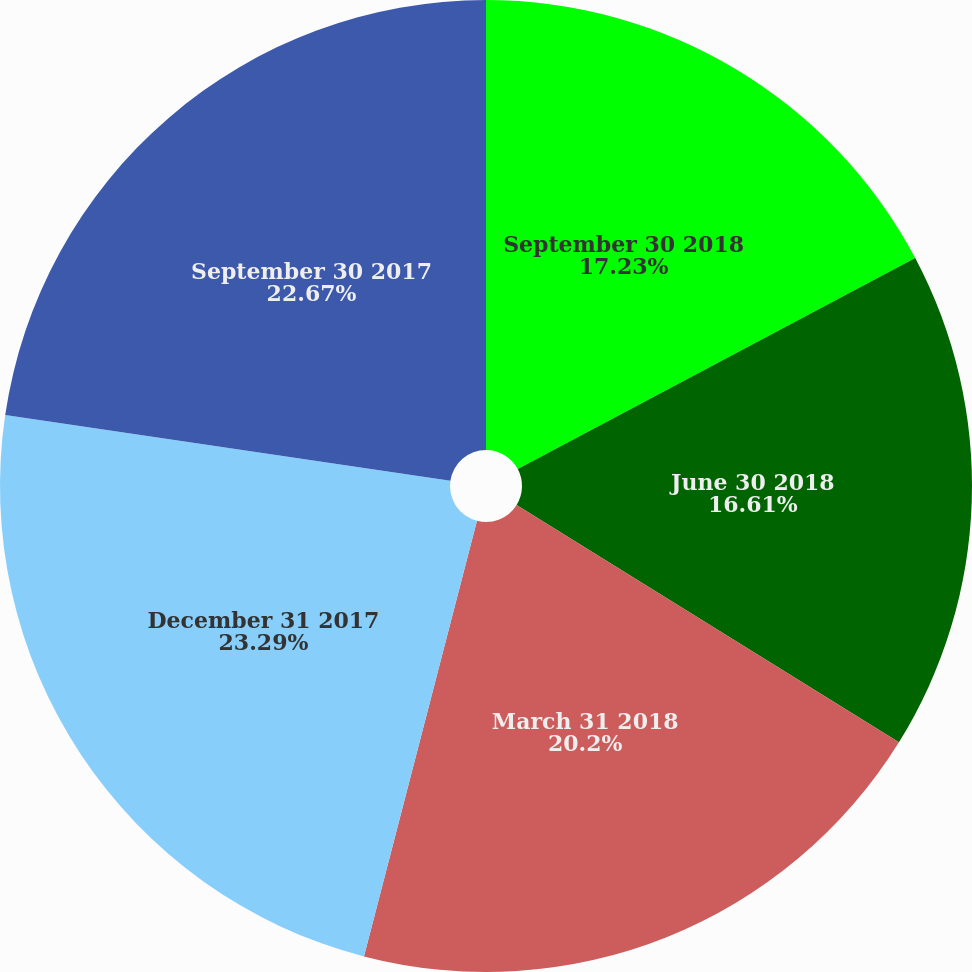Convert chart to OTSL. <chart><loc_0><loc_0><loc_500><loc_500><pie_chart><fcel>September 30 2018<fcel>June 30 2018<fcel>March 31 2018<fcel>December 31 2017<fcel>September 30 2017<nl><fcel>17.23%<fcel>16.61%<fcel>20.2%<fcel>23.29%<fcel>22.67%<nl></chart> 